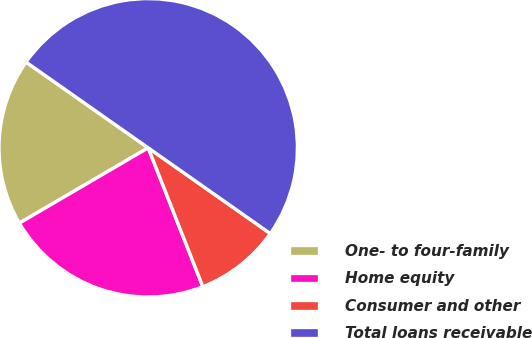Convert chart to OTSL. <chart><loc_0><loc_0><loc_500><loc_500><pie_chart><fcel>One- to four-family<fcel>Home equity<fcel>Consumer and other<fcel>Total loans receivable<nl><fcel>18.16%<fcel>22.55%<fcel>9.29%<fcel>50.0%<nl></chart> 